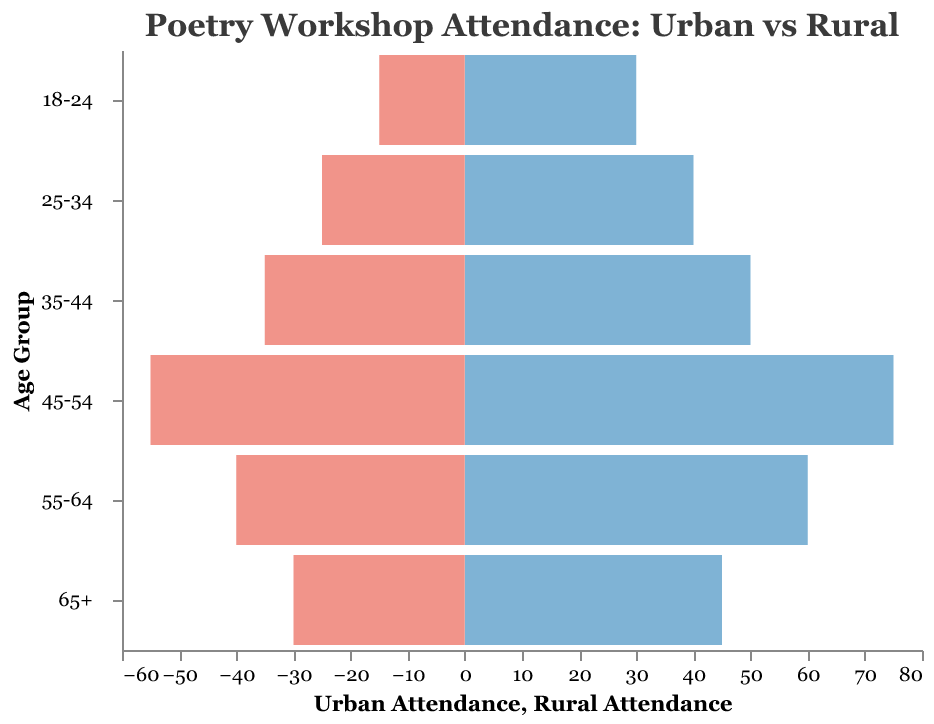What is the title of the figure? The title is located at the top of the figure and often describes what the graph is about.
Answer: Poetry Workshop Attendance: Urban vs Rural Which age group has the highest urban attendance? To find this, look at the urban attendance values (blue bars) and identify the longest bar.
Answer: 45-54 What is the total attendance for the 55-64 age group in both urban and rural areas? Total attendance is the sum of urban attendance and rural attendance for the 55-64 age group: 60 (urban) + 40 (rural).
Answer: 100 How does the attendance of the 35-44 age group compare between urban and rural areas? Compare the heights of the blue (urban) and red (rural) bars corresponding to the 35-44 age group. Urban attendance (50) is higher than rural attendance (35).
Answer: Urban attendance is higher by 15 What is the combined attendance for the youngest age group? Add the urban and rural attendance for the 18-24 age group: 30 (urban) + 15 (rural).
Answer: 45 Which age group has the smallest difference in attendance between urban and rural areas? Calculate the differences for each age group and find the smallest one. Differences are: 15 (65+), 20 (55-64), 20 (45-54), 15 (35-44), 15 (25-34), and 15 (18-24). The smallest difference is 15, occurring in multiple age groups.
Answer: 65+, 35-44, 25-34, 18-24 How many age groups have more urban than rural attendance? Count the number of age groups where the urban attendance bar (blue) is longer than the rural attendance bar (red). This occurs in all age groups.
Answer: 6 Rank the age groups in descending order based on their urban attendance. Arrange the urban attendance values in descending order: 45-54 (75), 55-64 (60), 65+ (45), 35-44 (50), 25-34 (40), 18-24 (30).
Answer: 45-54, 55-64, 35-44, 65+, 25-34, 18-24 What is the average urban attendance across all age groups? Sum the urban attendances and divide by the number of age groups: (45 + 60 + 75 + 50 + 40 + 30) / 6.
Answer: 50 What patterns can you observe in the urban and rural attendance across different age groups? By looking at the entire figure, one can see that urban attendance is consistently higher than rural attendance across all age groups. Urban attendance peaks at the 45-54 age group, while rural attendance also peaks in the same age group but with lower values.
Answer: Urban attendance is higher in all age groups; peaks in 45-54 age group for both urban and rural areas 